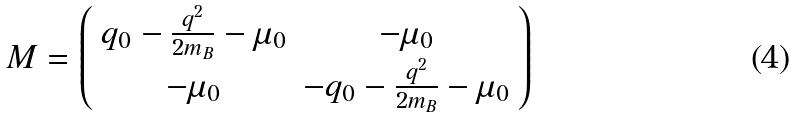Convert formula to latex. <formula><loc_0><loc_0><loc_500><loc_500>M = \left ( \begin{array} { c c } q _ { 0 } - \frac { q ^ { 2 } } { 2 m _ { B } } - \mu _ { 0 } & - \mu _ { 0 } \\ - \mu _ { 0 } & - q _ { 0 } - \frac { q ^ { 2 } } { 2 m _ { B } } - \mu _ { 0 } \end{array} \right )</formula> 